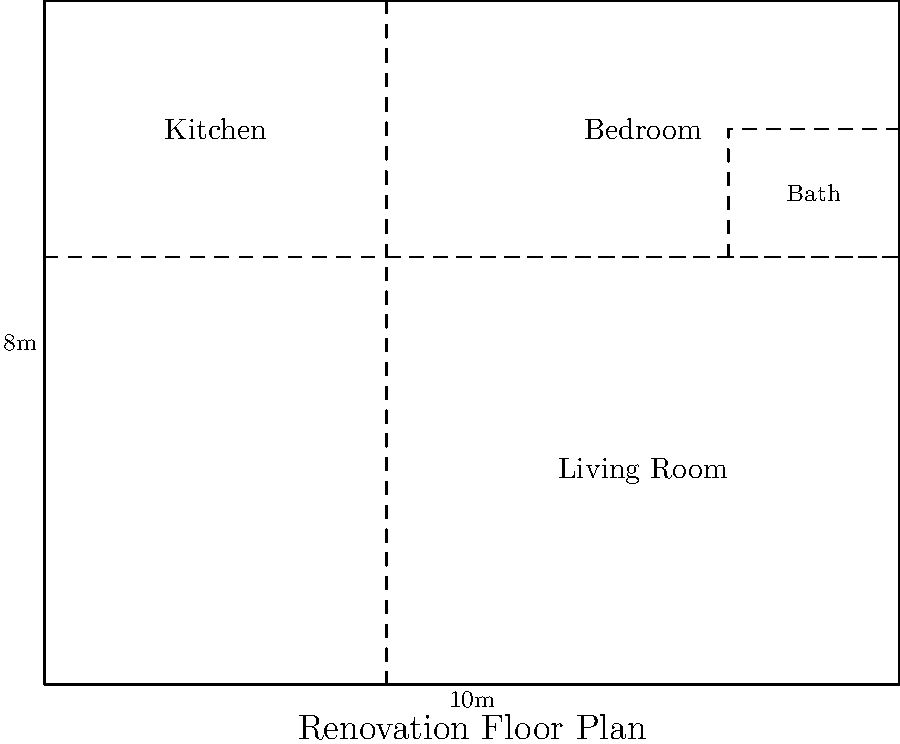As a construction project manager overseeing a renovation, you're presented with the floor plan above. The client wants to maximize the living room area by reducing the kitchen size. What is the maximum additional area (in square meters) that can be added to the living room if the kitchen is reduced to a minimum functional size of 3m x 3m? To solve this problem, let's follow these steps:

1. Calculate the current kitchen area:
   Current kitchen dimensions: 4m x 3m
   Current kitchen area = 4m * 3m = 12 m²

2. Calculate the minimum functional kitchen area:
   Minimum kitchen dimensions: 3m x 3m
   Minimum kitchen area = 3m * 3m = 9 m²

3. Calculate the difference between current and minimum kitchen areas:
   Area difference = Current kitchen area - Minimum kitchen area
   Area difference = 12 m² - 9 m² = 3 m²

4. This difference of 3 m² is the maximum additional area that can be added to the living room by reducing the kitchen size to its minimum functional dimensions.

5. Verify that this change is feasible within the given floor plan:
   - The kitchen can be reduced from 4m x 3m to 3m x 3m
   - The 1m reduction in width can be added to the living room
   - This change doesn't affect other areas of the floor plan

Therefore, the maximum additional area that can be added to the living room by reducing the kitchen size is 3 m².
Answer: 3 m² 